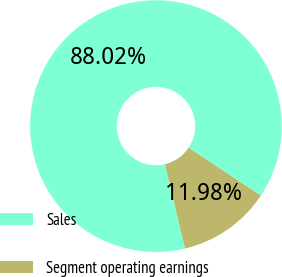Convert chart to OTSL. <chart><loc_0><loc_0><loc_500><loc_500><pie_chart><fcel>Sales<fcel>Segment operating earnings<nl><fcel>88.02%<fcel>11.98%<nl></chart> 